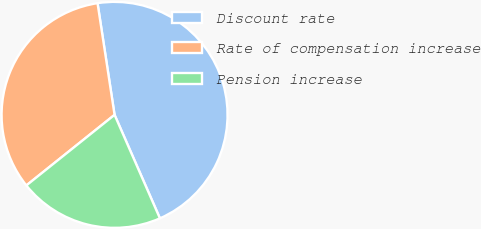<chart> <loc_0><loc_0><loc_500><loc_500><pie_chart><fcel>Discount rate<fcel>Rate of compensation increase<fcel>Pension increase<nl><fcel>45.83%<fcel>33.33%<fcel>20.83%<nl></chart> 